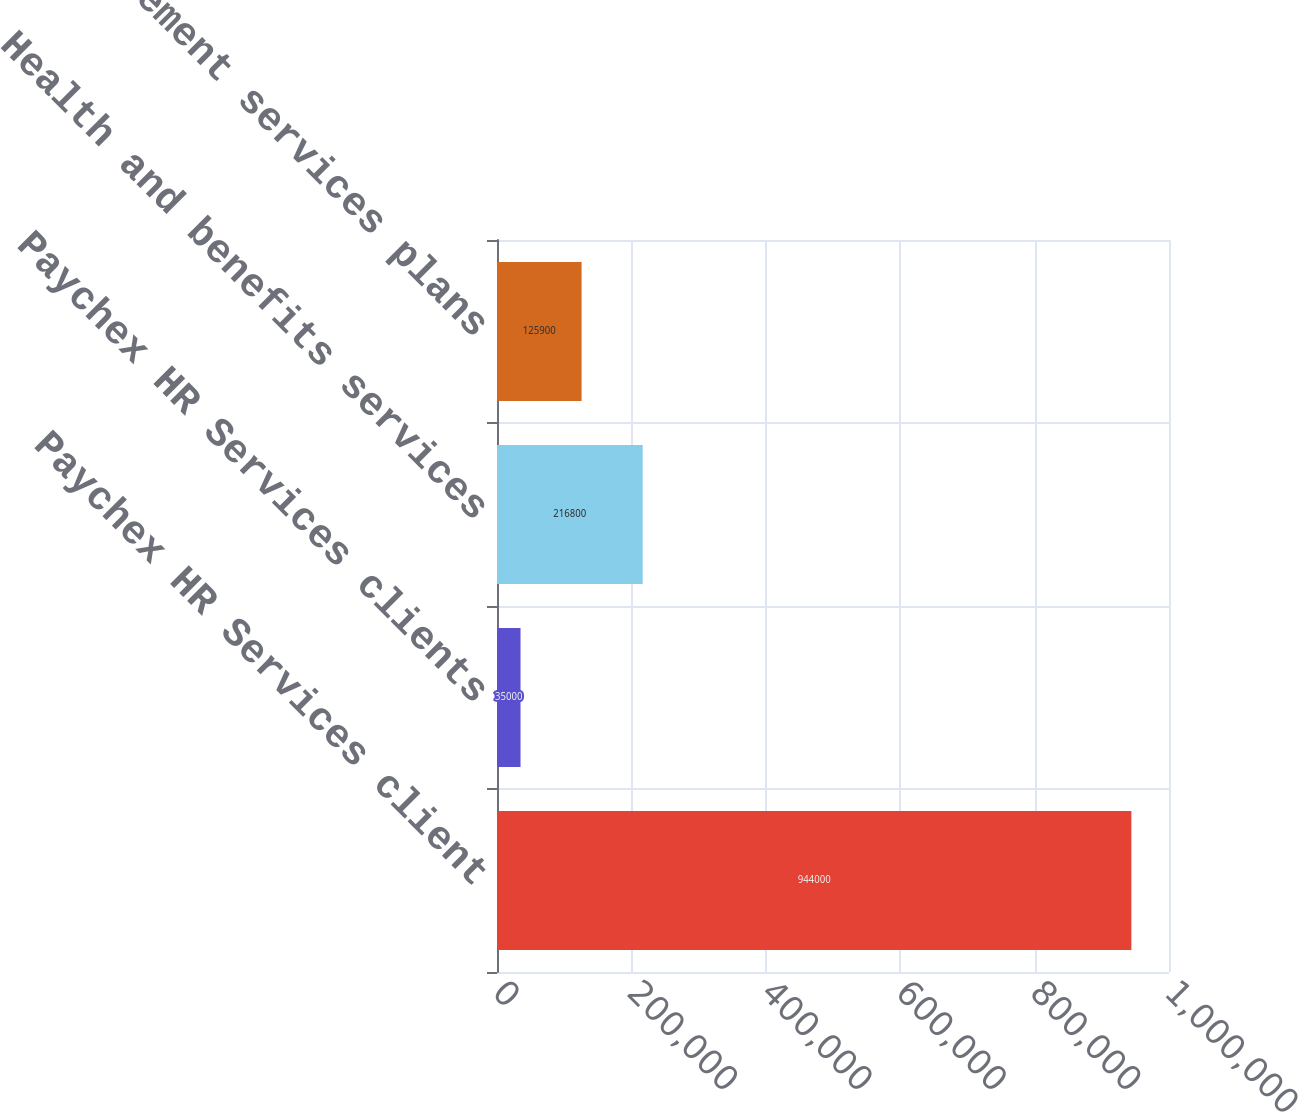Convert chart. <chart><loc_0><loc_0><loc_500><loc_500><bar_chart><fcel>Paychex HR Services client<fcel>Paychex HR Services clients<fcel>Health and benefits services<fcel>Retirement services plans<nl><fcel>944000<fcel>35000<fcel>216800<fcel>125900<nl></chart> 